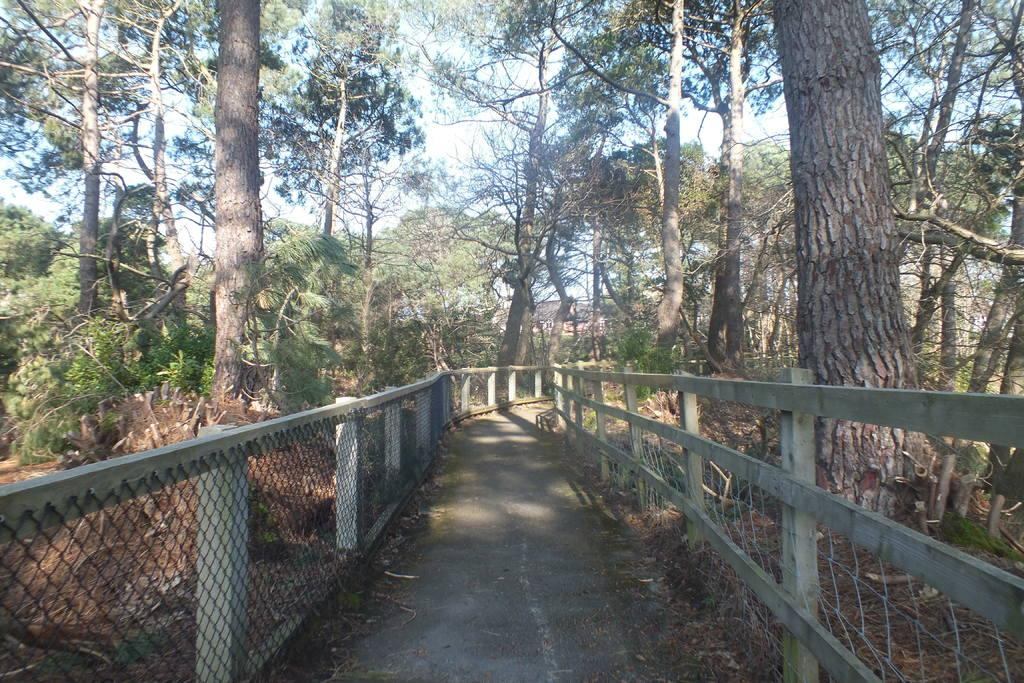What type of path can be seen in the image? There is a pathway in the image. What is located alongside the pathway? There is a fence in the image. What type of vegetation is present in the image? There are trees with branches and leaves in the image. What type of footwear is the lawyer wearing in the afternoon in the image? There is no lawyer or afternoon mentioned in the image, and no footwear is visible. 